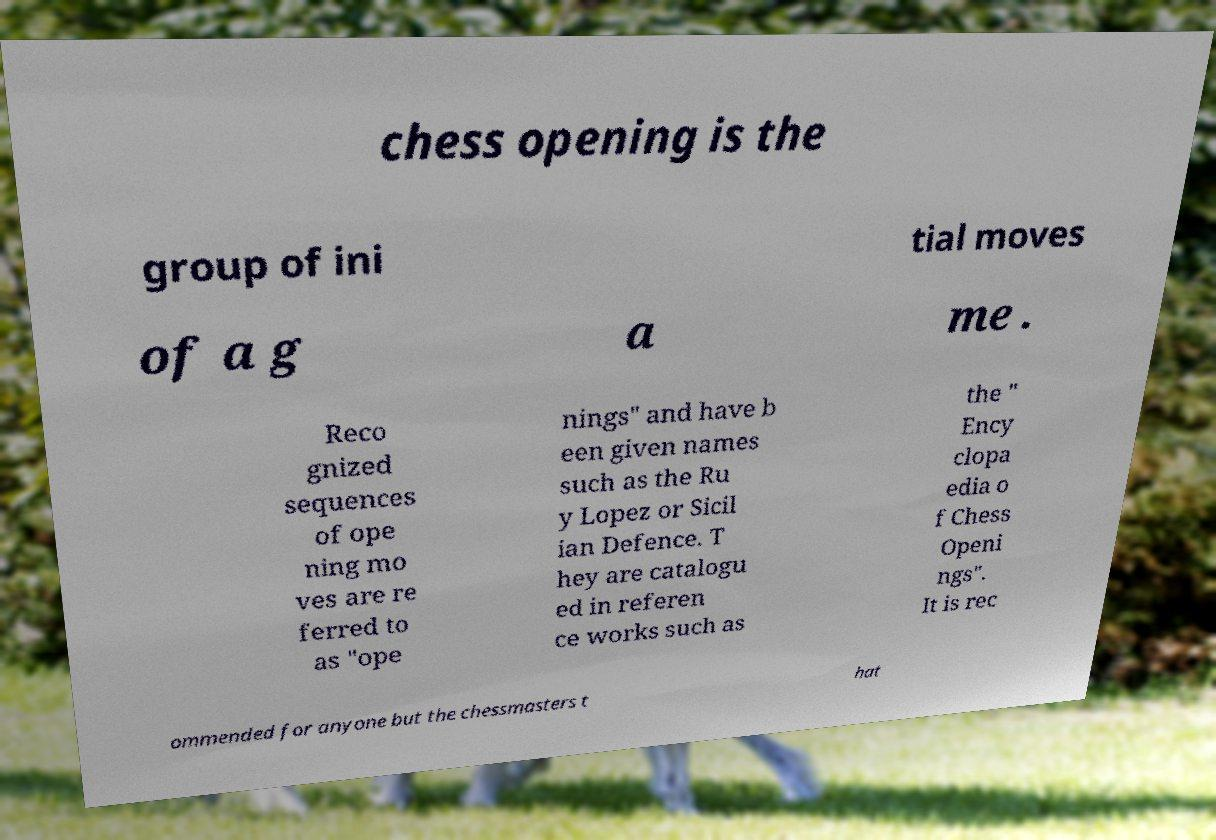There's text embedded in this image that I need extracted. Can you transcribe it verbatim? chess opening is the group of ini tial moves of a g a me . Reco gnized sequences of ope ning mo ves are re ferred to as "ope nings" and have b een given names such as the Ru y Lopez or Sicil ian Defence. T hey are catalogu ed in referen ce works such as the " Ency clopa edia o f Chess Openi ngs". It is rec ommended for anyone but the chessmasters t hat 